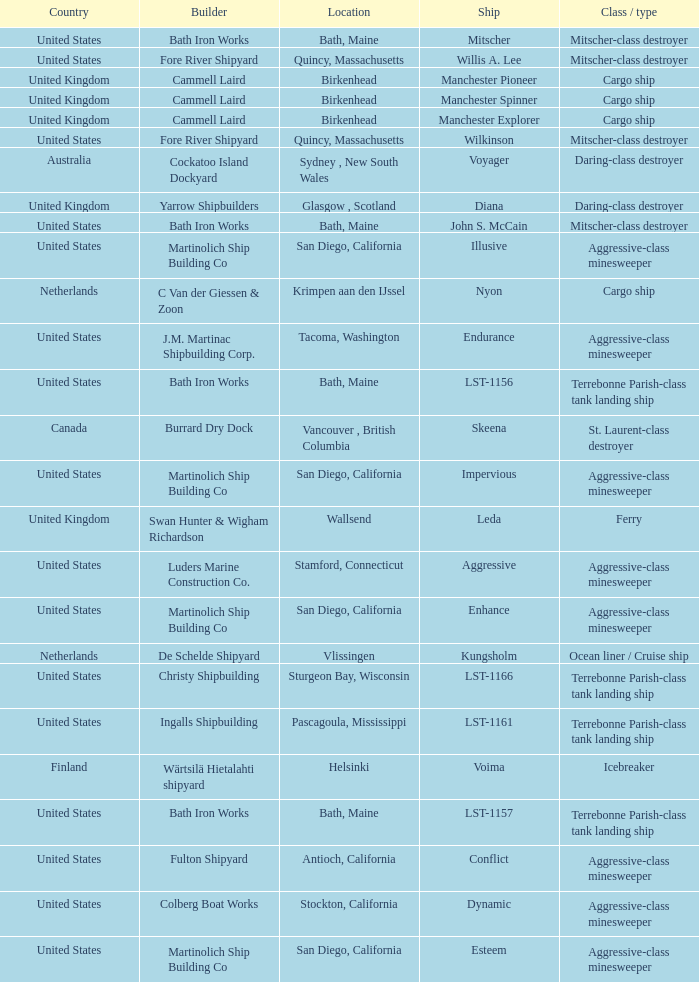What Country is the John S. McCain Ship from? United States. 